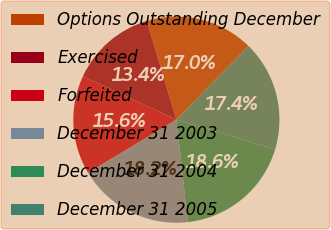<chart> <loc_0><loc_0><loc_500><loc_500><pie_chart><fcel>Options Outstanding December<fcel>Exercised<fcel>Forfeited<fcel>December 31 2003<fcel>December 31 2004<fcel>December 31 2005<nl><fcel>16.95%<fcel>13.42%<fcel>15.56%<fcel>18.16%<fcel>18.56%<fcel>17.35%<nl></chart> 